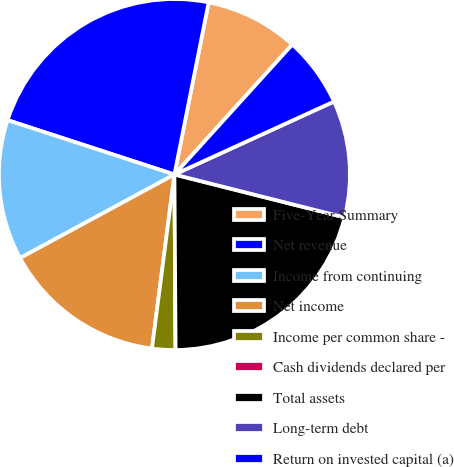<chart> <loc_0><loc_0><loc_500><loc_500><pie_chart><fcel>Five-Year Summary<fcel>Net revenue<fcel>Income from continuing<fcel>Net income<fcel>Income per common share -<fcel>Cash dividends declared per<fcel>Total assets<fcel>Long-term debt<fcel>Return on invested capital (a)<nl><fcel>8.6%<fcel>23.11%<fcel>12.91%<fcel>15.06%<fcel>2.15%<fcel>0.0%<fcel>20.96%<fcel>10.76%<fcel>6.45%<nl></chart> 